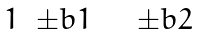<formula> <loc_0><loc_0><loc_500><loc_500>\begin{array} { c c } 1 & \pm b { 1 } \end{array} \quad \begin{array} { c c } \pm b { 2 } \end{array}</formula> 